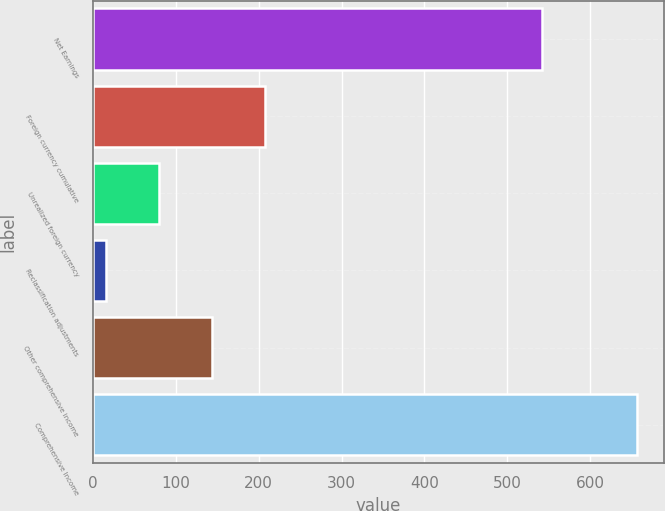Convert chart. <chart><loc_0><loc_0><loc_500><loc_500><bar_chart><fcel>Net Earnings<fcel>Foreign currency cumulative<fcel>Unrealized foreign currency<fcel>Reclassification adjustments<fcel>Other comprehensive income<fcel>Comprehensive Income<nl><fcel>541.8<fcel>207.91<fcel>79.77<fcel>15.7<fcel>143.84<fcel>656.4<nl></chart> 